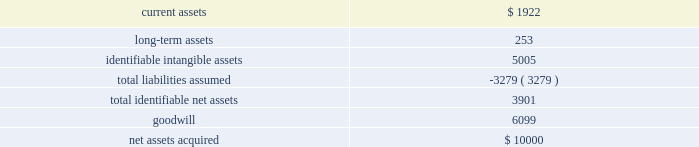58 2016 annual report note 12 .
Business acquisition bayside business solutions , inc .
Effective july 1 , 2015 , the company acquired all of the equity interests of bayside business solutions , an alabama-based company that provides technology solutions and payment processing services primarily for the financial services industry , for $ 10000 paid in cash .
This acquisition was funded using existing operating cash .
The acquisition of bayside business solutions expanded the company 2019s presence in commercial lending within the industry .
Management has completed a purchase price allocation of bayside business solutions and its assessment of the fair value of acquired assets and liabilities assumed .
The recognized amounts of identifiable assets acquired and liabilities assumed , based upon their fair values as of july 1 , 2015 are set forth below: .
The goodwill of $ 6099 arising from this acquisition consists largely of the growth potential , synergies and economies of scale expected from combining the operations of the company with those of bayside business solutions , together with the value of bayside business solutions 2019 assembled workforce .
Goodwill from this acquisition has been allocated to our banking systems and services segment .
The goodwill is not expected to be deductible for income tax purposes .
Identifiable intangible assets from this acquisition consist of customer relationships of $ 3402 , $ 659 of computer software and other intangible assets of $ 944 .
The weighted average amortization period for acquired customer relationships , acquired computer software , and other intangible assets is 15 years , 5 years , and 20 years , respectively .
Current assets were inclusive of cash acquired of $ 1725 .
The fair value of current assets acquired included accounts receivable of $ 178 .
The gross amount of receivables was $ 178 , none of which was expected to be uncollectible .
During fiscal year 2016 , the company incurred $ 55 in costs related to the acquisition of bayside business solutions .
These costs included fees for legal , valuation and other fees .
These costs were included within general and administrative expenses .
The results of bayside business solutions 2019 operations included in the company 2019s consolidated statement of income for the twelve months ended june 30 , 2016 included revenue of $ 4273 and after-tax net income of $ 303 .
The accompanying consolidated statements of income for the fiscal year ended june 30 , 2016 do not include any revenues and expenses related to this acquisition prior to the acquisition date .
The impact of this acquisition was considered immaterial to both the current and prior periods of our consolidated financial statements and pro forma financial information has not been provided .
Banno , llc effective march 1 , 2014 , the company acquired all of the equity interests of banno , an iowa-based company that provides web and transaction marketing services with a focus on the mobile medium , for $ 27910 paid in cash .
This acquisition was funded using existing operating cash .
The acquisition of banno expanded the company 2019s presence in online and mobile technologies within the industry .
During fiscal year 2014 , the company incurred $ 30 in costs related to the acquisition of banno .
These costs included fees for legal , valuation and other fees .
These costs were included within general and administrative expenses .
The results of banno's operations included in the company's consolidated statements of income for the year ended june 30 , 2016 included revenue of $ 6393 and after-tax net loss of $ 1289 .
For the year ended june 30 , 2015 , our consolidated statements of income included revenue of $ 4175 and after-tax net loss of $ 1784 attributable to banno .
The results of banno 2019s operations included in the company 2019s consolidated statement of operations from the acquisition date to june 30 , 2014 included revenue of $ 848 and after-tax net loss of $ 1121 .
The accompanying consolidated statements of income for the twelve month period ended june 30 , 2016 do not include any revenues and expenses related to this acquisition prior to the acquisition date .
The impact of this acquisition was considered immaterial to both the current and prior periods of our consolidated financial statements and pro forma financial information has not been provided. .
What were net assets in millions acquired net of accounts receivable? 
Computations: (10000 - 178)
Answer: 9822.0. 